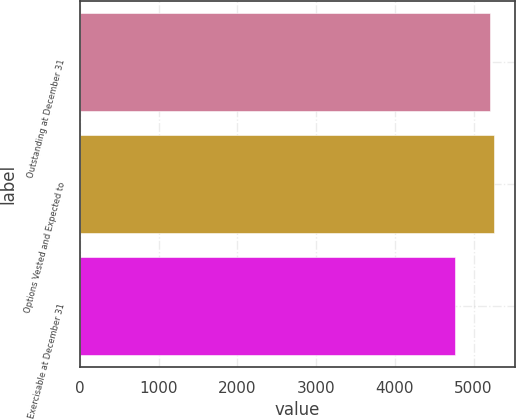<chart> <loc_0><loc_0><loc_500><loc_500><bar_chart><fcel>Outstanding at December 31<fcel>Options Vested and Expected to<fcel>Exercisable at December 31<nl><fcel>5212<fcel>5257.3<fcel>4759<nl></chart> 